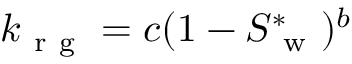Convert formula to latex. <formula><loc_0><loc_0><loc_500><loc_500>k _ { r g } = c ( 1 - S _ { w } ^ { * } ) ^ { b }</formula> 